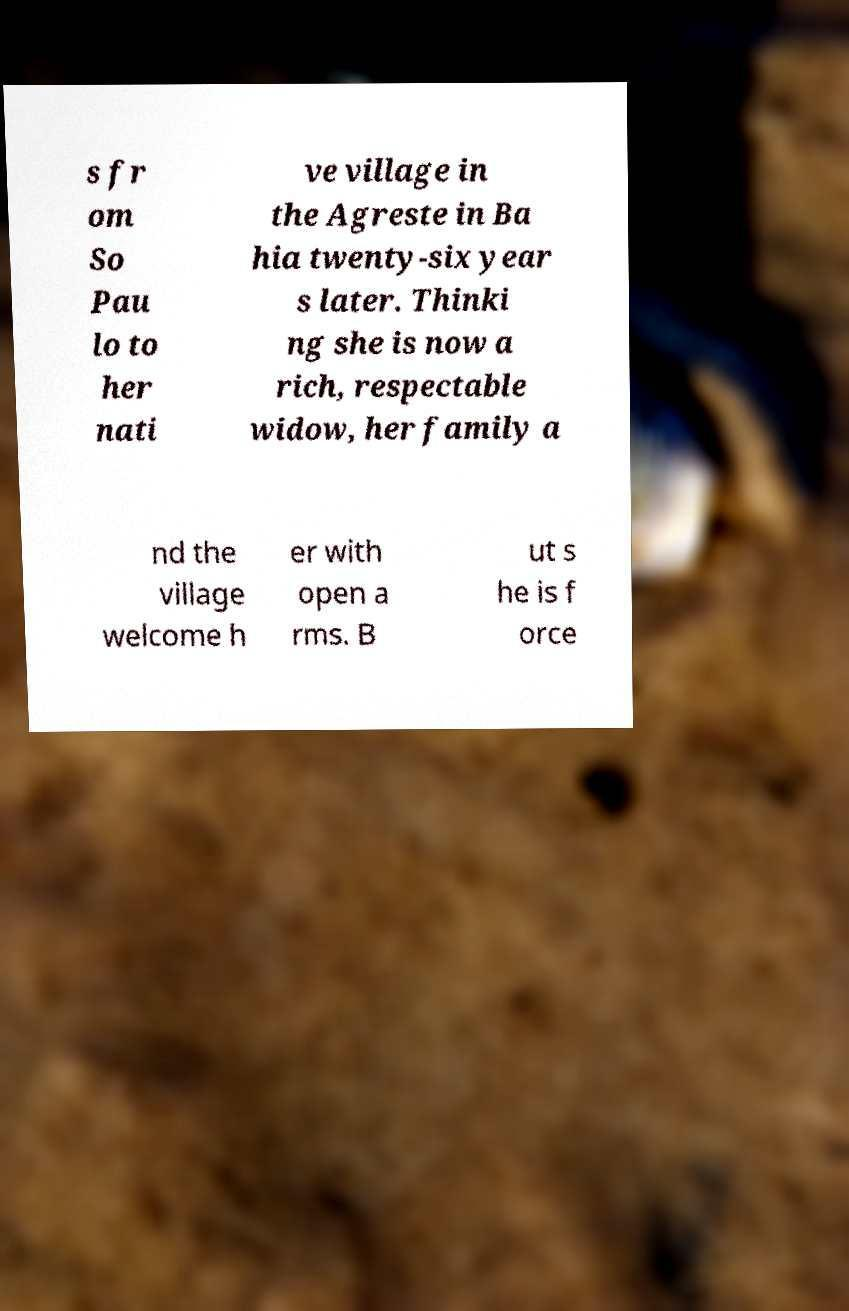Please identify and transcribe the text found in this image. s fr om So Pau lo to her nati ve village in the Agreste in Ba hia twenty-six year s later. Thinki ng she is now a rich, respectable widow, her family a nd the village welcome h er with open a rms. B ut s he is f orce 